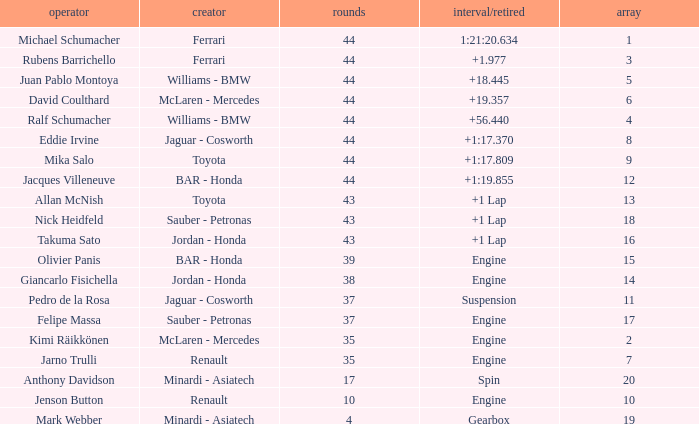What was the time of the driver on grid 3? 1.977. 